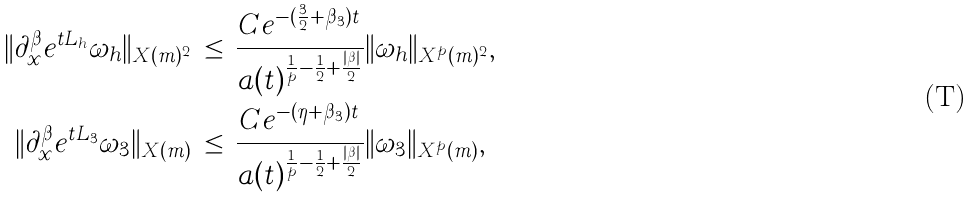Convert formula to latex. <formula><loc_0><loc_0><loc_500><loc_500>\| \partial _ { x } ^ { \beta } e ^ { t L _ { h } } \omega _ { h } \| _ { X ( m ) ^ { 2 } } \, & \leq \, \frac { C e ^ { - ( \frac { 3 } { 2 } + \beta _ { 3 } ) t } } { a ( t ) ^ { \frac { 1 } { p } - \frac { 1 } { 2 } + \frac { | \beta | } { 2 } } } \| \omega _ { h } \| _ { X ^ { p } ( m ) ^ { 2 } } , \\ \| \partial _ { x } ^ { \beta } e ^ { t L _ { 3 } } \omega _ { 3 } \| _ { X ( m ) } \, & \leq \, \frac { C e ^ { - ( \eta + \beta _ { 3 } ) t } } { a ( t ) ^ { \frac { 1 } { p } - \frac { 1 } { 2 } + \frac { | \beta | } { 2 } } } \| \omega _ { 3 } \| _ { X ^ { p } ( m ) } ,</formula> 